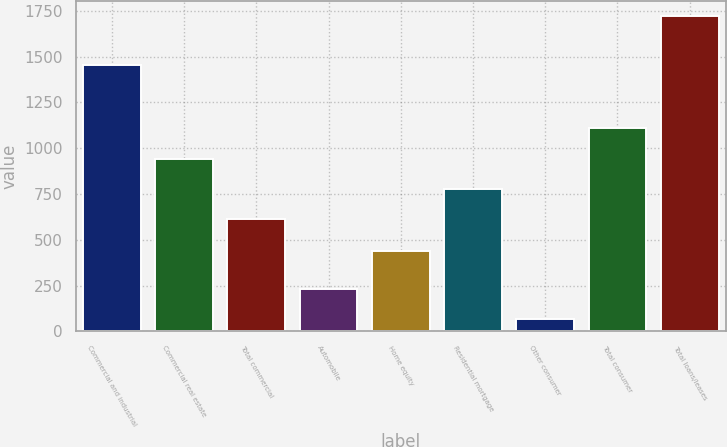Convert chart to OTSL. <chart><loc_0><loc_0><loc_500><loc_500><bar_chart><fcel>Commercial and industrial<fcel>Commercial real estate<fcel>Total commercial<fcel>Automobile<fcel>Home equity<fcel>Residential mortgage<fcel>Other consumer<fcel>Total consumer<fcel>Total loans/leases<nl><fcel>1452<fcel>942.8<fcel>612<fcel>230.4<fcel>440<fcel>777.4<fcel>65<fcel>1108.2<fcel>1719<nl></chart> 